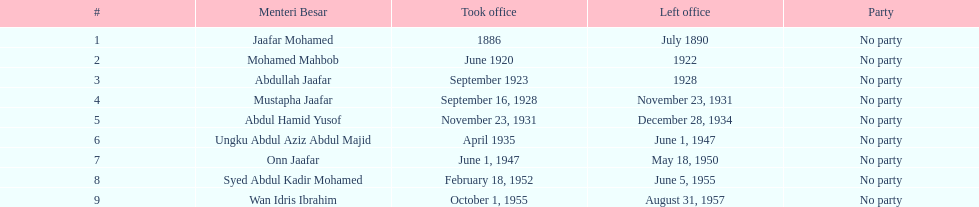For what duration did ungku abdul aziz abdul majid hold his position? 12 years. 